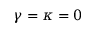<formula> <loc_0><loc_0><loc_500><loc_500>\gamma = \kappa = 0</formula> 